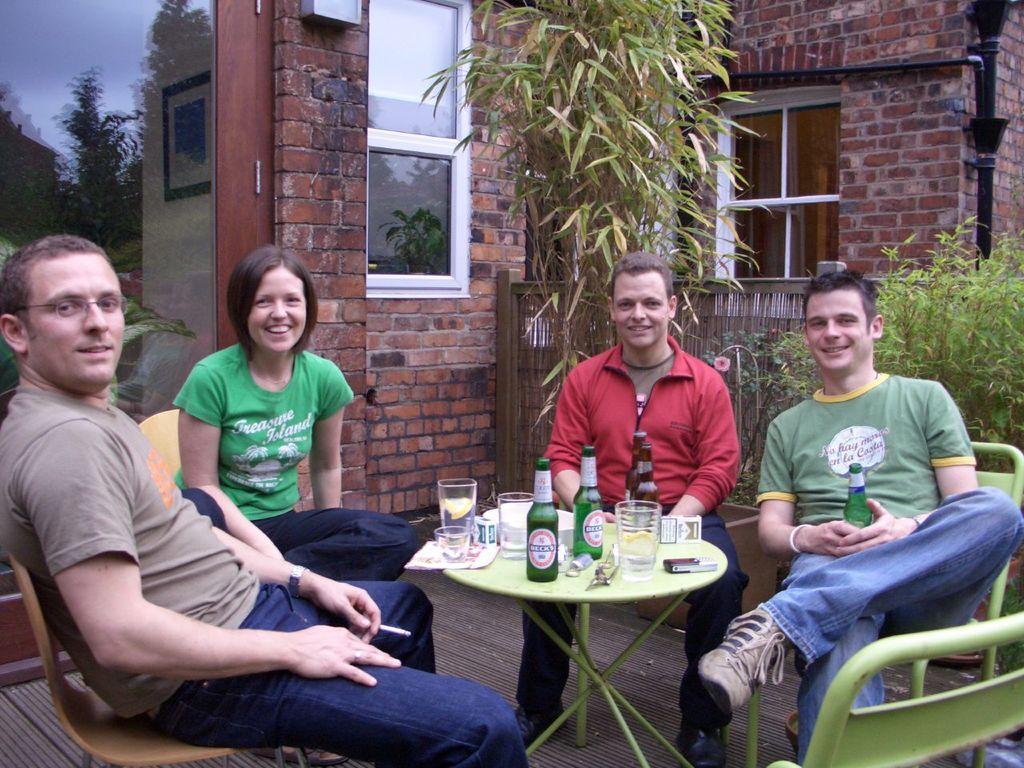Can you describe this image briefly? There are four people sitting on chairs. On the right the person is holding a bottle. On the left a person is wearing specs and watch. In front of them there is a table. On the table there are bottles, glasses and some other items. In the background there is a building with big wall. window, trees, plants and a wooden fencing. 